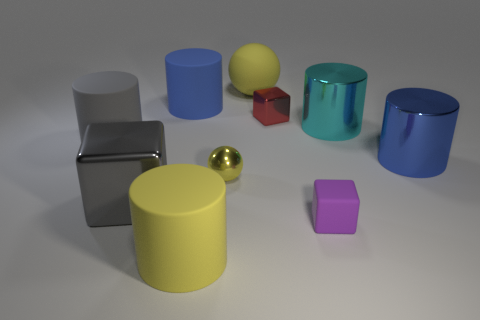Subtract all cyan cylinders. How many cylinders are left? 4 Subtract all red cylinders. Subtract all blue cubes. How many cylinders are left? 5 Subtract all cubes. How many objects are left? 7 Add 9 matte cubes. How many matte cubes are left? 10 Add 8 big gray cylinders. How many big gray cylinders exist? 9 Subtract 0 red cylinders. How many objects are left? 10 Subtract all small gray matte cylinders. Subtract all red blocks. How many objects are left? 9 